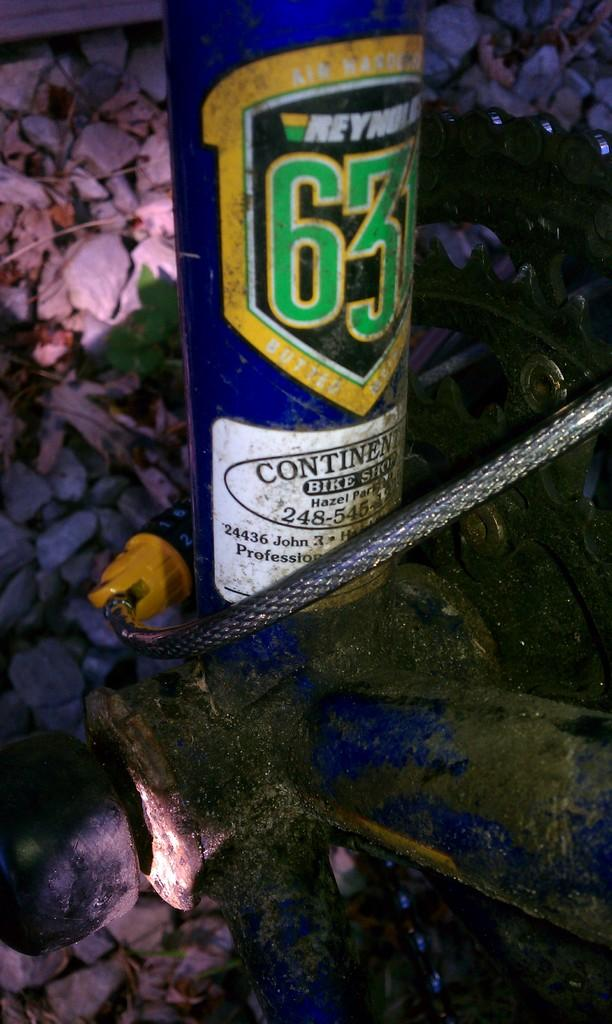<image>
Relay a brief, clear account of the picture shown. Bike lock wrapped around a can from Continental Bike Shop. 